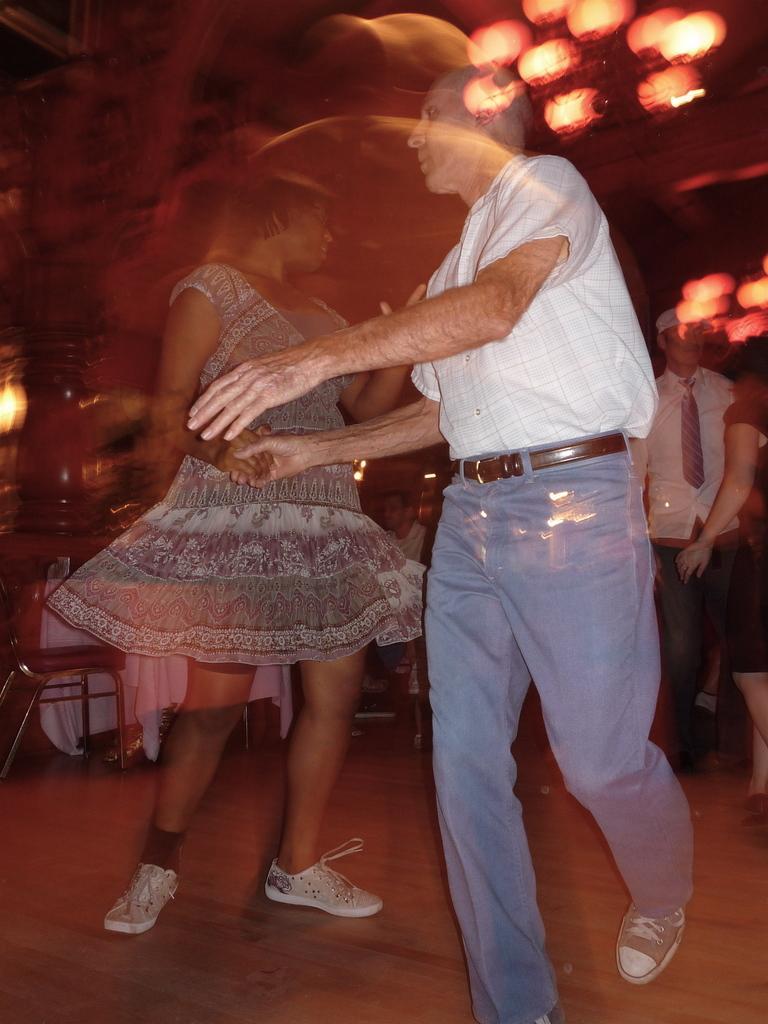Please provide a concise description of this image. In this image we can see a few people dancing on the floor, also we can see a person sitting on the chair, there is a table covered with a white color cloth, at the top we can see some lights. 